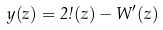<formula> <loc_0><loc_0><loc_500><loc_500>y ( z ) = 2 \omega ( z ) - W ^ { \prime } ( z )</formula> 